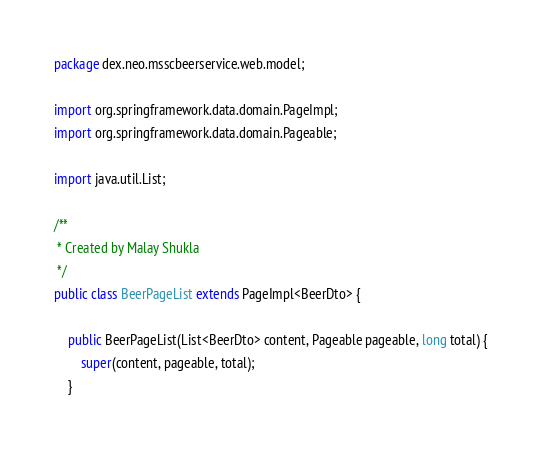<code> <loc_0><loc_0><loc_500><loc_500><_Java_>package dex.neo.msscbeerservice.web.model;

import org.springframework.data.domain.PageImpl;
import org.springframework.data.domain.Pageable;

import java.util.List;

/**
 * Created by Malay Shukla
 */
public class BeerPageList extends PageImpl<BeerDto> {

    public BeerPageList(List<BeerDto> content, Pageable pageable, long total) {
        super(content, pageable, total);
    }
</code> 